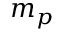Convert formula to latex. <formula><loc_0><loc_0><loc_500><loc_500>m _ { p }</formula> 